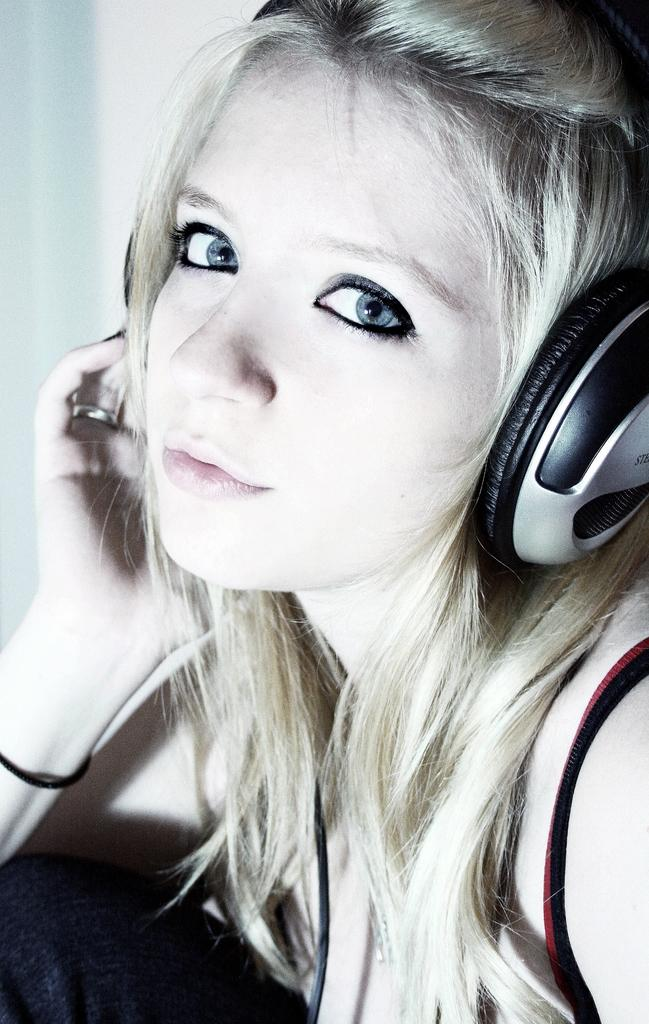Who is present in the image? There is a woman in the image. What is the woman wearing on her ears? The woman is wearing headphones. What type of can is visible in the image? There is no can present in the image. What color are the woman's trousers in the image? The provided facts do not mention the color or type of trousers the woman is wearing. Is there a lamp visible in the image? There is no lamp mentioned or visible in the image. 